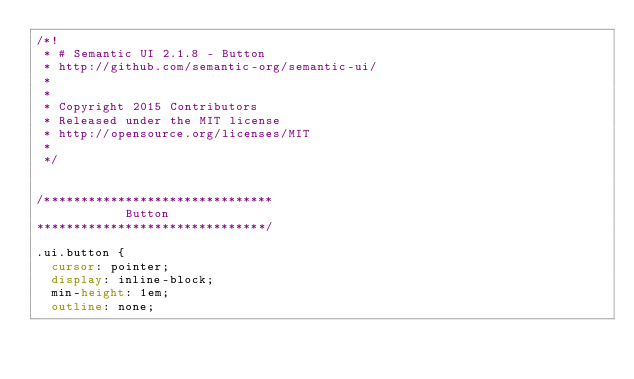Convert code to text. <code><loc_0><loc_0><loc_500><loc_500><_CSS_>/*!
 * # Semantic UI 2.1.8 - Button
 * http://github.com/semantic-org/semantic-ui/
 *
 *
 * Copyright 2015 Contributors
 * Released under the MIT license
 * http://opensource.org/licenses/MIT
 *
 */


/*******************************
            Button
*******************************/

.ui.button {
  cursor: pointer;
  display: inline-block;
  min-height: 1em;
  outline: none;</code> 